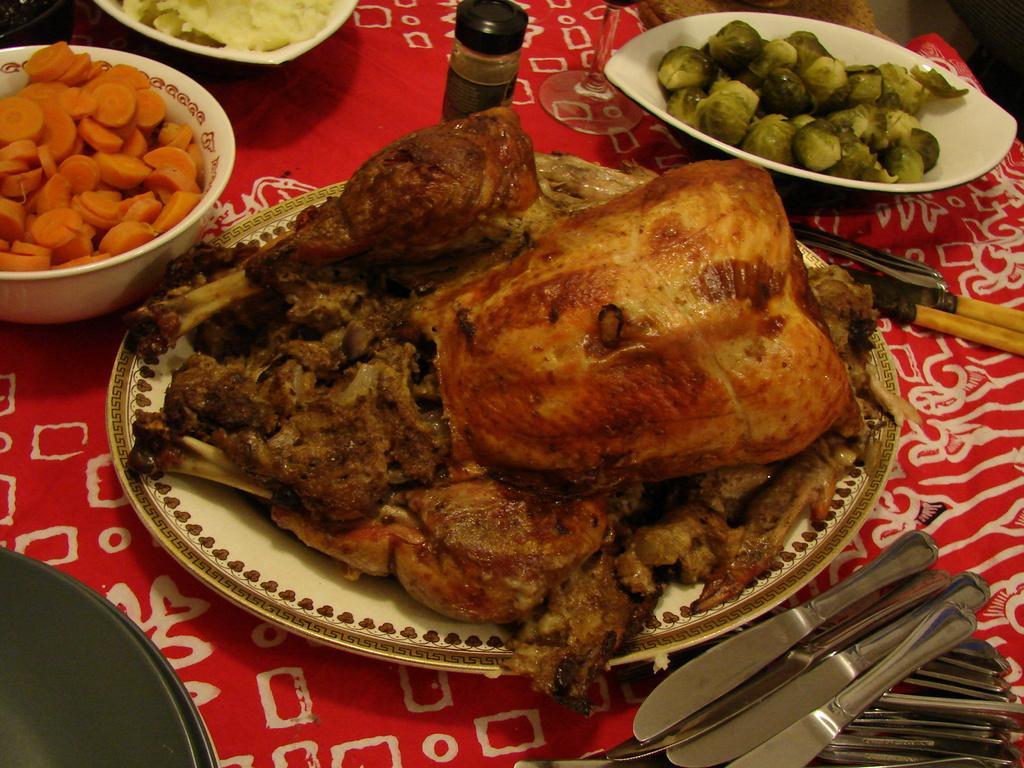Can you describe this image briefly? In this picture, we can see some food items served in plate and bowl, and we can see some objects on the table and the table is covered with cloth. 